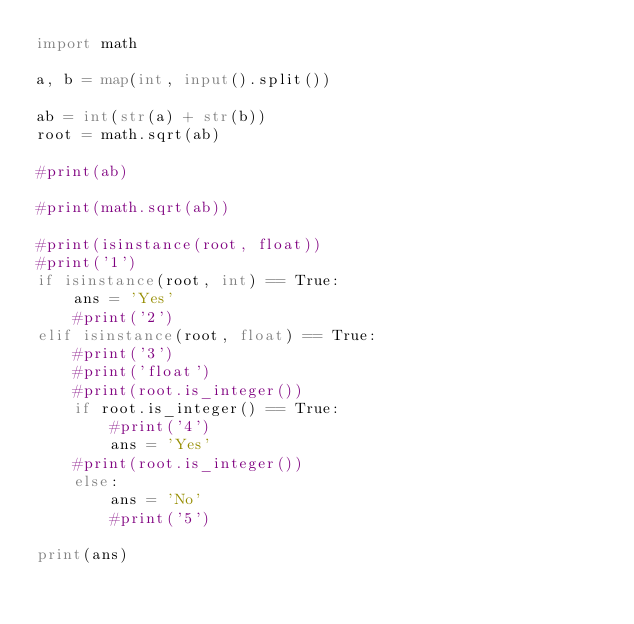<code> <loc_0><loc_0><loc_500><loc_500><_Python_>import math

a, b = map(int, input().split())

ab = int(str(a) + str(b)) 
root = math.sqrt(ab)

#print(ab)

#print(math.sqrt(ab))

#print(isinstance(root, float))
#print('1')
if isinstance(root, int) == True:
    ans = 'Yes' 
    #print('2')
elif isinstance(root, float) == True:
    #print('3')
    #print('float')
    #print(root.is_integer())
    if root.is_integer() == True:
        #print('4')
        ans = 'Yes' 
    #print(root.is_integer())
    else:
        ans = 'No'
        #print('5')

print(ans)</code> 